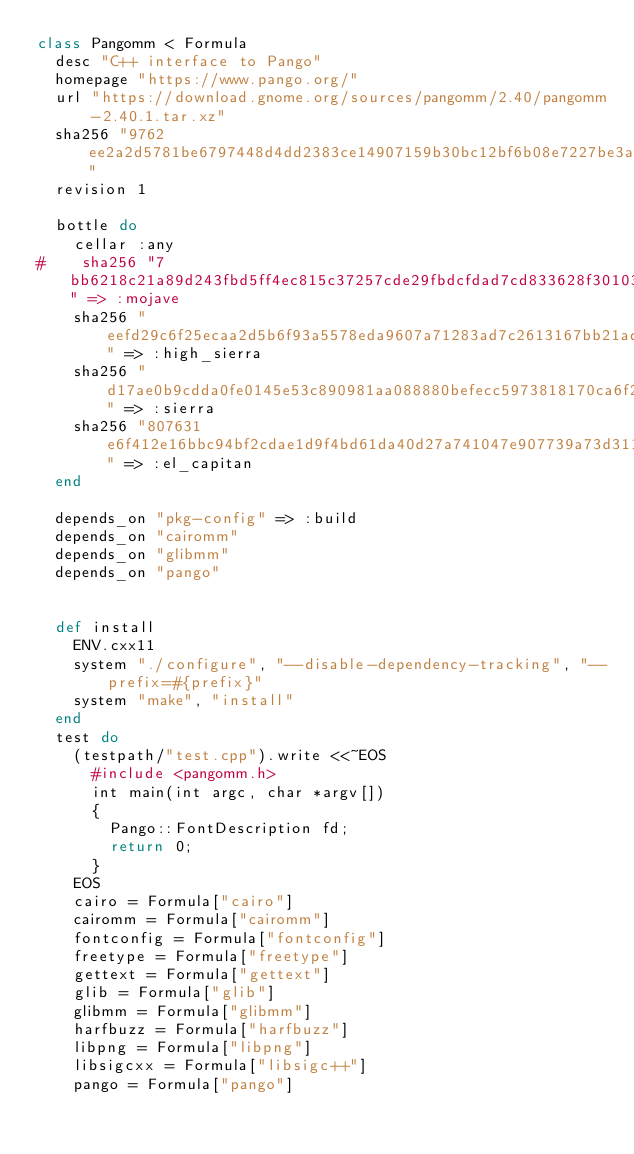<code> <loc_0><loc_0><loc_500><loc_500><_Ruby_>class Pangomm < Formula
  desc "C++ interface to Pango"
  homepage "https://www.pango.org/"
  url "https://download.gnome.org/sources/pangomm/2.40/pangomm-2.40.1.tar.xz"
  sha256 "9762ee2a2d5781be6797448d4dd2383ce14907159b30bc12bf6b08e7227be3af"
  revision 1

  bottle do
    cellar :any
#    sha256 "7bb6218c21a89d243fbd5ff4ec815c37257cde29fbdcfdad7cd833628f30103a" => :mojave
    sha256 "eefd29c6f25ecaa2d5b6f93a5578eda9607a71283ad7c2613167bb21ad4c62d4" => :high_sierra
    sha256 "d17ae0b9cdda0fe0145e53c890981aa088880befecc5973818170ca6f2b39c6b" => :sierra
    sha256 "807631e6f412e16bbc94bf2cdae1d9f4bd61da40d27a741047e907739a73d311" => :el_capitan
  end

  depends_on "pkg-config" => :build
  depends_on "cairomm"
  depends_on "glibmm"
  depends_on "pango"


  def install
    ENV.cxx11
    system "./configure", "--disable-dependency-tracking", "--prefix=#{prefix}"
    system "make", "install"
  end
  test do
    (testpath/"test.cpp").write <<~EOS
      #include <pangomm.h>
      int main(int argc, char *argv[])
      {
        Pango::FontDescription fd;
        return 0;
      }
    EOS
    cairo = Formula["cairo"]
    cairomm = Formula["cairomm"]
    fontconfig = Formula["fontconfig"]
    freetype = Formula["freetype"]
    gettext = Formula["gettext"]
    glib = Formula["glib"]
    glibmm = Formula["glibmm"]
    harfbuzz = Formula["harfbuzz"]
    libpng = Formula["libpng"]
    libsigcxx = Formula["libsigc++"]
    pango = Formula["pango"]</code> 